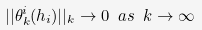<formula> <loc_0><loc_0><loc_500><loc_500>| | \theta ^ { i } _ { k } ( h _ { i } ) | | _ { k } \rightarrow 0 \ a s \ k \rightarrow \infty</formula> 